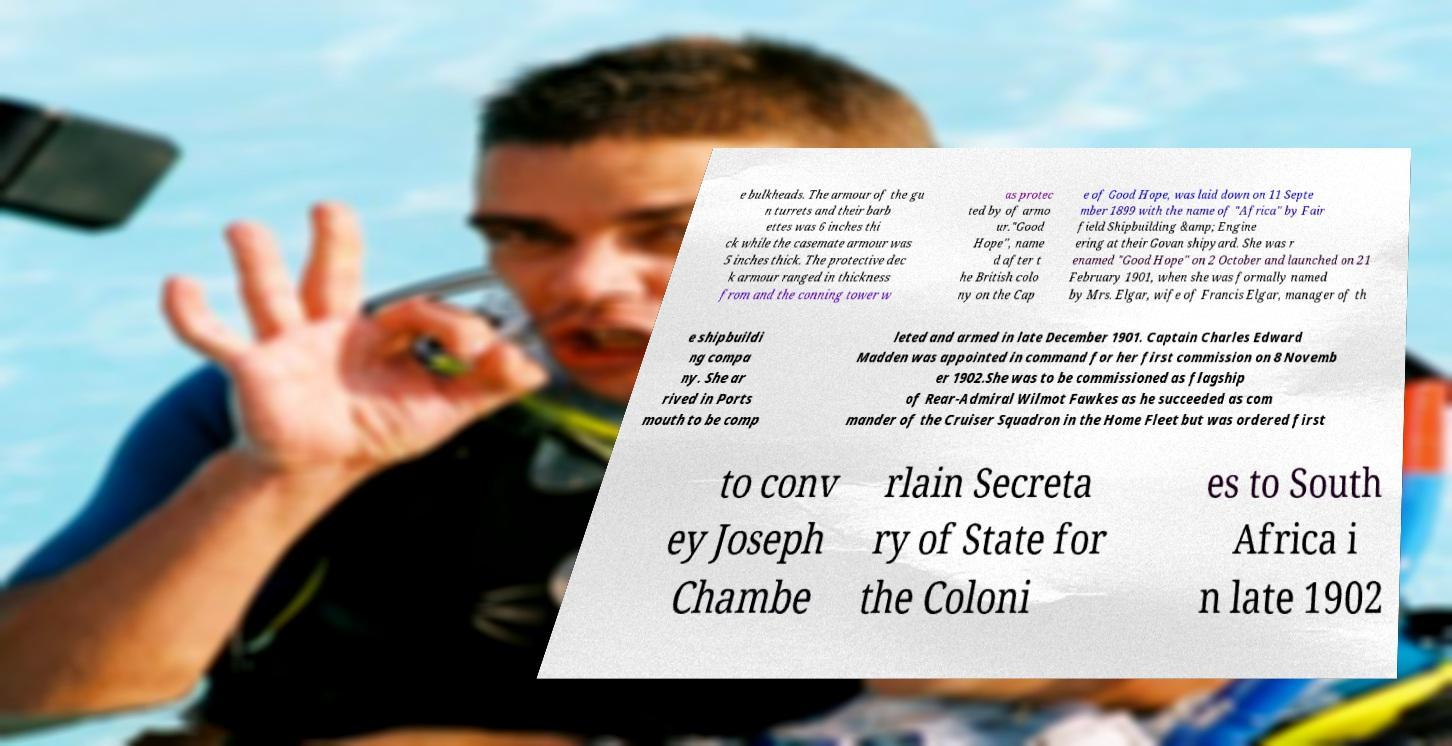Can you read and provide the text displayed in the image?This photo seems to have some interesting text. Can you extract and type it out for me? e bulkheads. The armour of the gu n turrets and their barb ettes was 6 inches thi ck while the casemate armour was 5 inches thick. The protective dec k armour ranged in thickness from and the conning tower w as protec ted by of armo ur."Good Hope", name d after t he British colo ny on the Cap e of Good Hope, was laid down on 11 Septe mber 1899 with the name of "Africa" by Fair field Shipbuilding &amp; Engine ering at their Govan shipyard. She was r enamed "Good Hope" on 2 October and launched on 21 February 1901, when she was formally named by Mrs. Elgar, wife of Francis Elgar, manager of th e shipbuildi ng compa ny. She ar rived in Ports mouth to be comp leted and armed in late December 1901. Captain Charles Edward Madden was appointed in command for her first commission on 8 Novemb er 1902.She was to be commissioned as flagship of Rear-Admiral Wilmot Fawkes as he succeeded as com mander of the Cruiser Squadron in the Home Fleet but was ordered first to conv ey Joseph Chambe rlain Secreta ry of State for the Coloni es to South Africa i n late 1902 